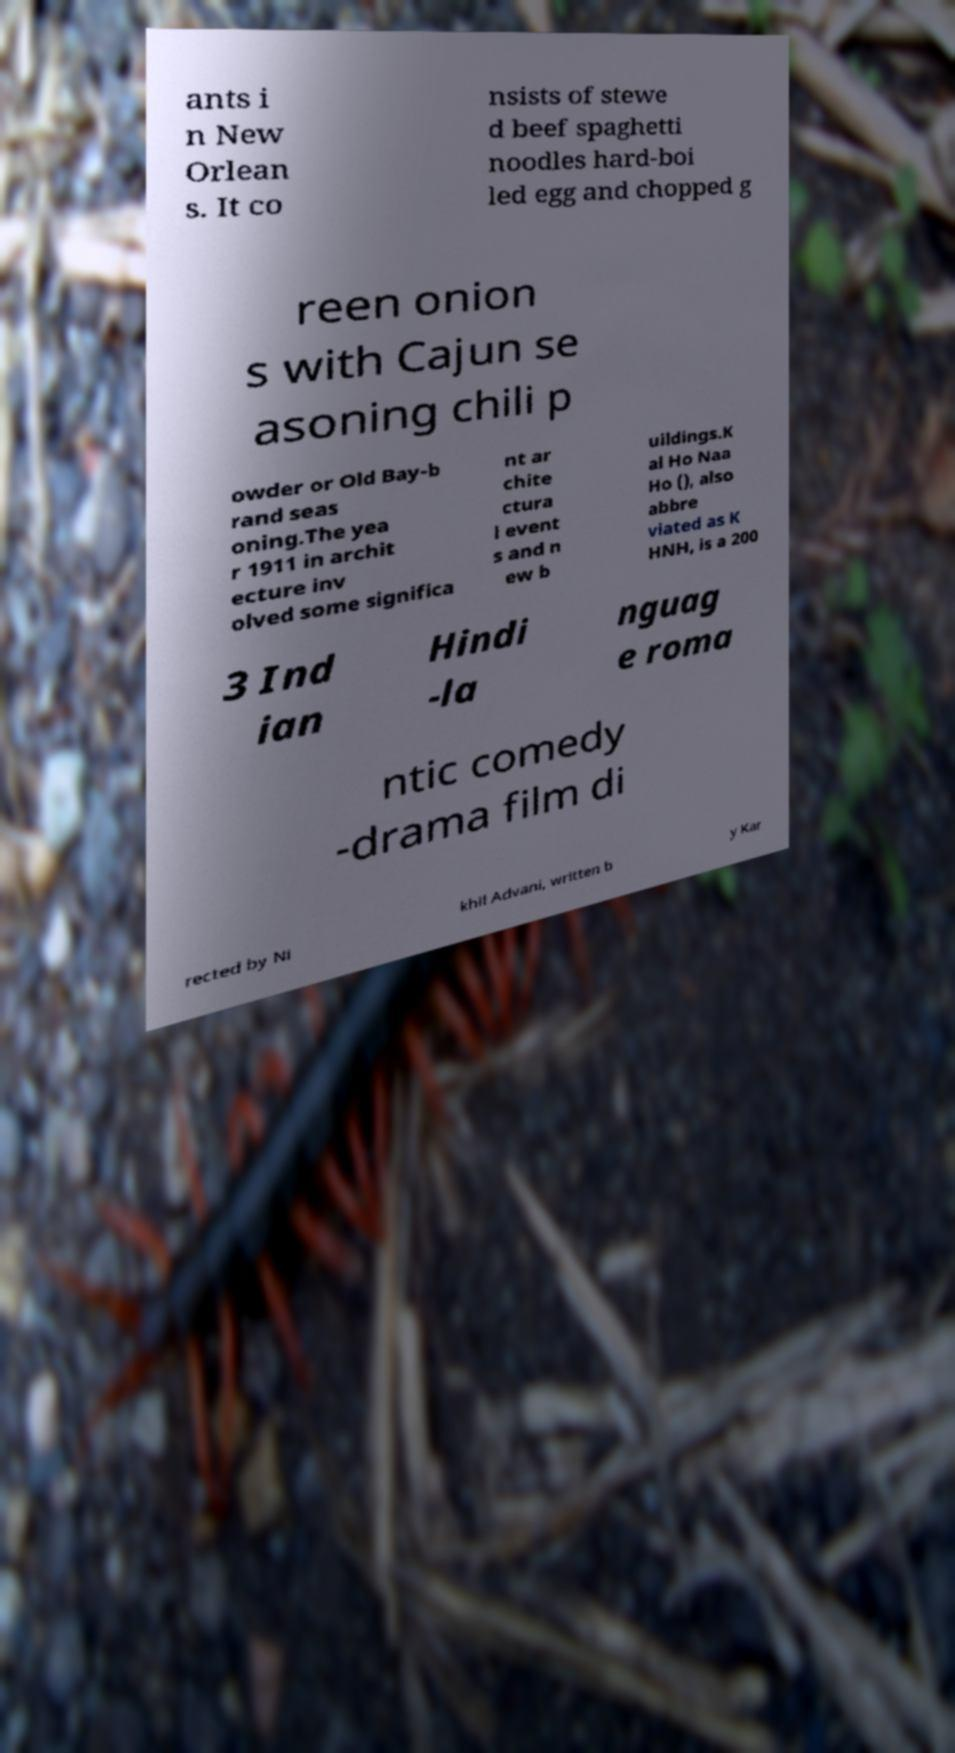Please read and relay the text visible in this image. What does it say? ants i n New Orlean s. It co nsists of stewe d beef spaghetti noodles hard-boi led egg and chopped g reen onion s with Cajun se asoning chili p owder or Old Bay-b rand seas oning.The yea r 1911 in archit ecture inv olved some significa nt ar chite ctura l event s and n ew b uildings.K al Ho Naa Ho (), also abbre viated as K HNH, is a 200 3 Ind ian Hindi -la nguag e roma ntic comedy -drama film di rected by Ni khil Advani, written b y Kar 